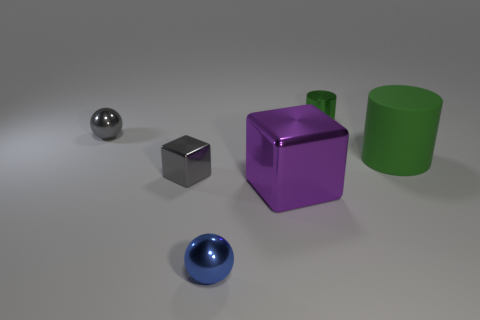Add 2 tiny purple things. How many objects exist? 8 Subtract all cubes. How many objects are left? 4 Subtract 0 cyan balls. How many objects are left? 6 Subtract all tiny green matte things. Subtract all large metal objects. How many objects are left? 5 Add 1 big shiny objects. How many big shiny objects are left? 2 Add 3 cubes. How many cubes exist? 5 